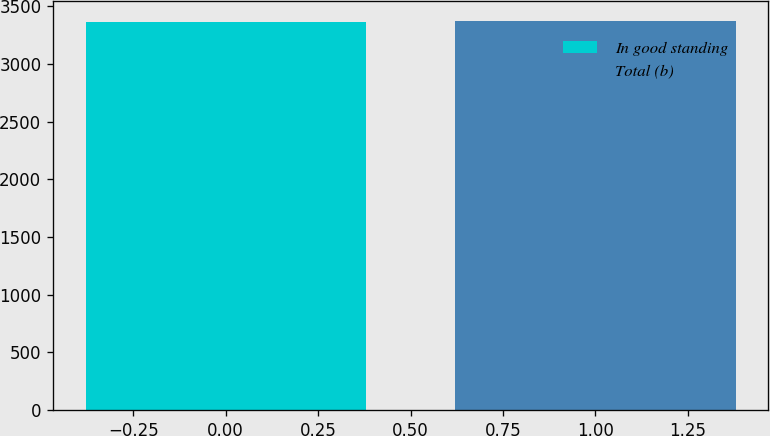<chart> <loc_0><loc_0><loc_500><loc_500><bar_chart><fcel>In good standing<fcel>Total (b)<nl><fcel>3364<fcel>3375<nl></chart> 